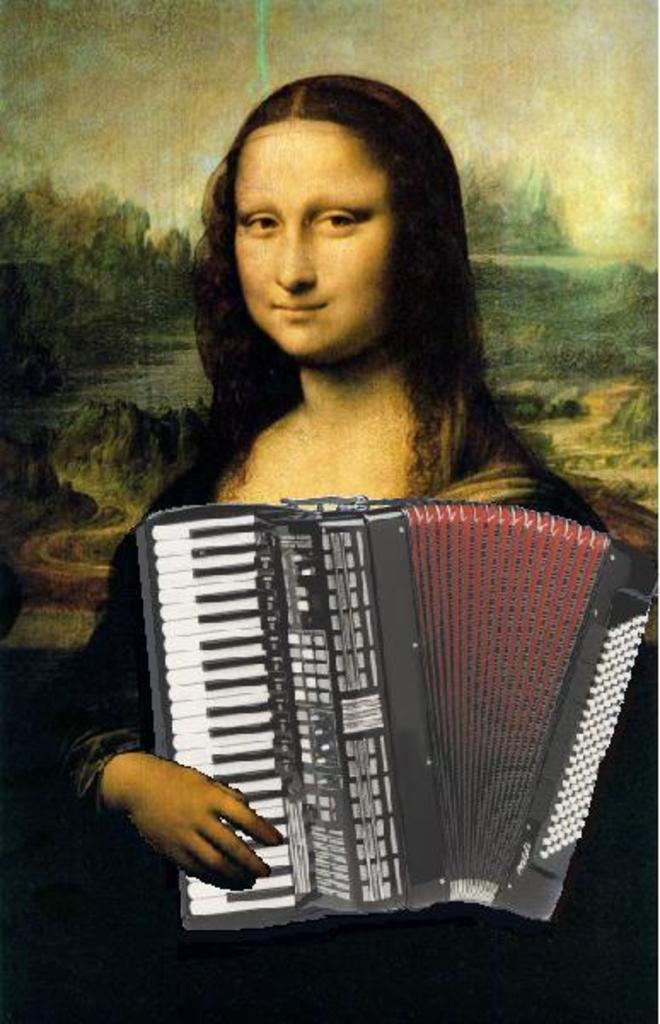What famous artwork is depicted in the image? There is a Mona Lisa painting in the image. What musical instrument is visible at the front of the image? There is a harmonium at the front of the image. Where is the desk located in the image? There is no desk present in the image. How many tomatoes are on the harmonium in the image? There are no tomatoes present in the image. 